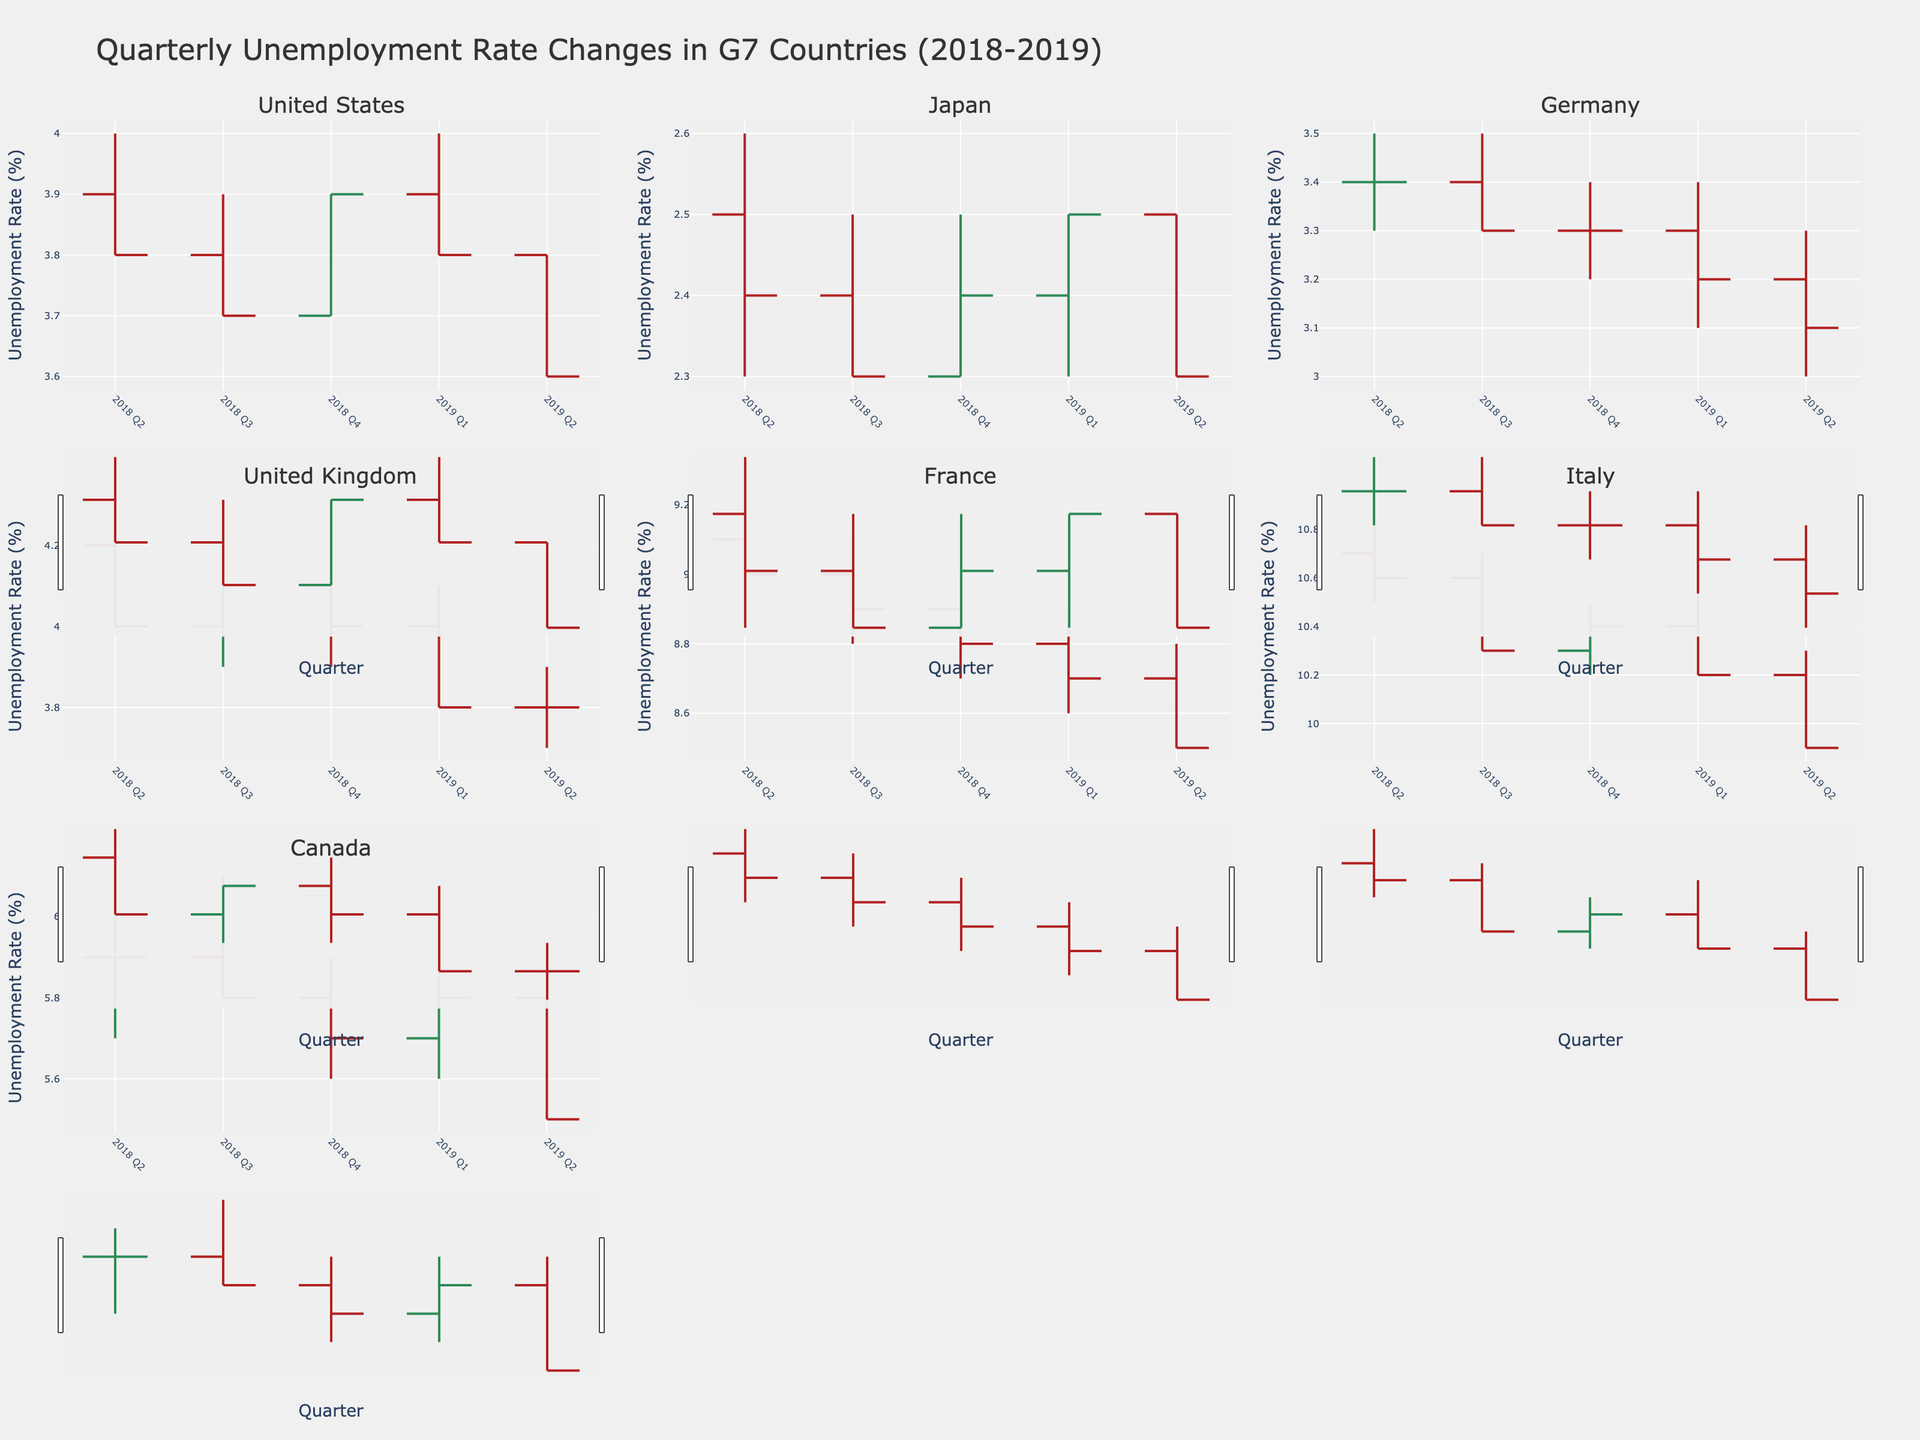Which country has the lowest unemployment rate in Q2 of 2019? To find out which country has the lowest unemployment rate in Q2 of 2019, look at the "Close" value for each country in that quarter. Comparing all the values, Japan has the lowest at 2.3%.
Answer: Japan What is the general trend of the unemployment rate in Italy from 2018 Q2 to 2019 Q2? To determine the trend, examine the "Close" values for each quarter. Starting at 10.6 in 2018 Q2, the rate decreases to 9.9 by 2019 Q2. This indicates a general downward trend.
Answer: Downward Which country experienced the largest range (difference between high and low) in unemployment rate in any given quarter? Identify the biggest range by subtracting the "Low" value from the "High" value for each country and quarter. France in 2019 Q1 has the largest range of 0.3 (8.9 - 8.6).
Answer: France How many countries show a consistent decrease in their unemployment rate from 2018 Q2 to 2019 Q2? To find this, check the "Close" values from 2018 Q2 to 2019 Q2 for each country. The countries with consistently decreasing values are France, Italy, and Germany.
Answer: Three For the United States, which quarter had the highest unemployment rate within the given period? Look at the "High" values for each quarter for the United States. The highest rate is 4.0 in 2018 Q2 and 2019 Q1.
Answer: 2018 Q2, 2019 Q1 What is the average unemployment rate for Canada over the provided period? Calculate the average by summing the "Close" values for Canada and dividing by the number of quarters (5.9 + 5.8 + 5.7 + 5.8 + 5.5)/5 = 5.74%.
Answer: 5.74% Between Japan and Germany, which country had a more volatile unemployment rate? A volatile rate implies frequent or large changes. By observing the fluctuations in "Close" values, Germany’s rate changes more frequently compared to Japan's, signaling higher volatility.
Answer: Germany 